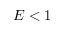Convert formula to latex. <formula><loc_0><loc_0><loc_500><loc_500>E < 1</formula> 